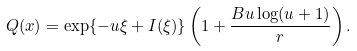<formula> <loc_0><loc_0><loc_500><loc_500>Q ( x ) = \exp \{ - u \xi + I ( \xi ) \} \left ( 1 + \frac { B u \log ( u + 1 ) } { r } \right ) .</formula> 